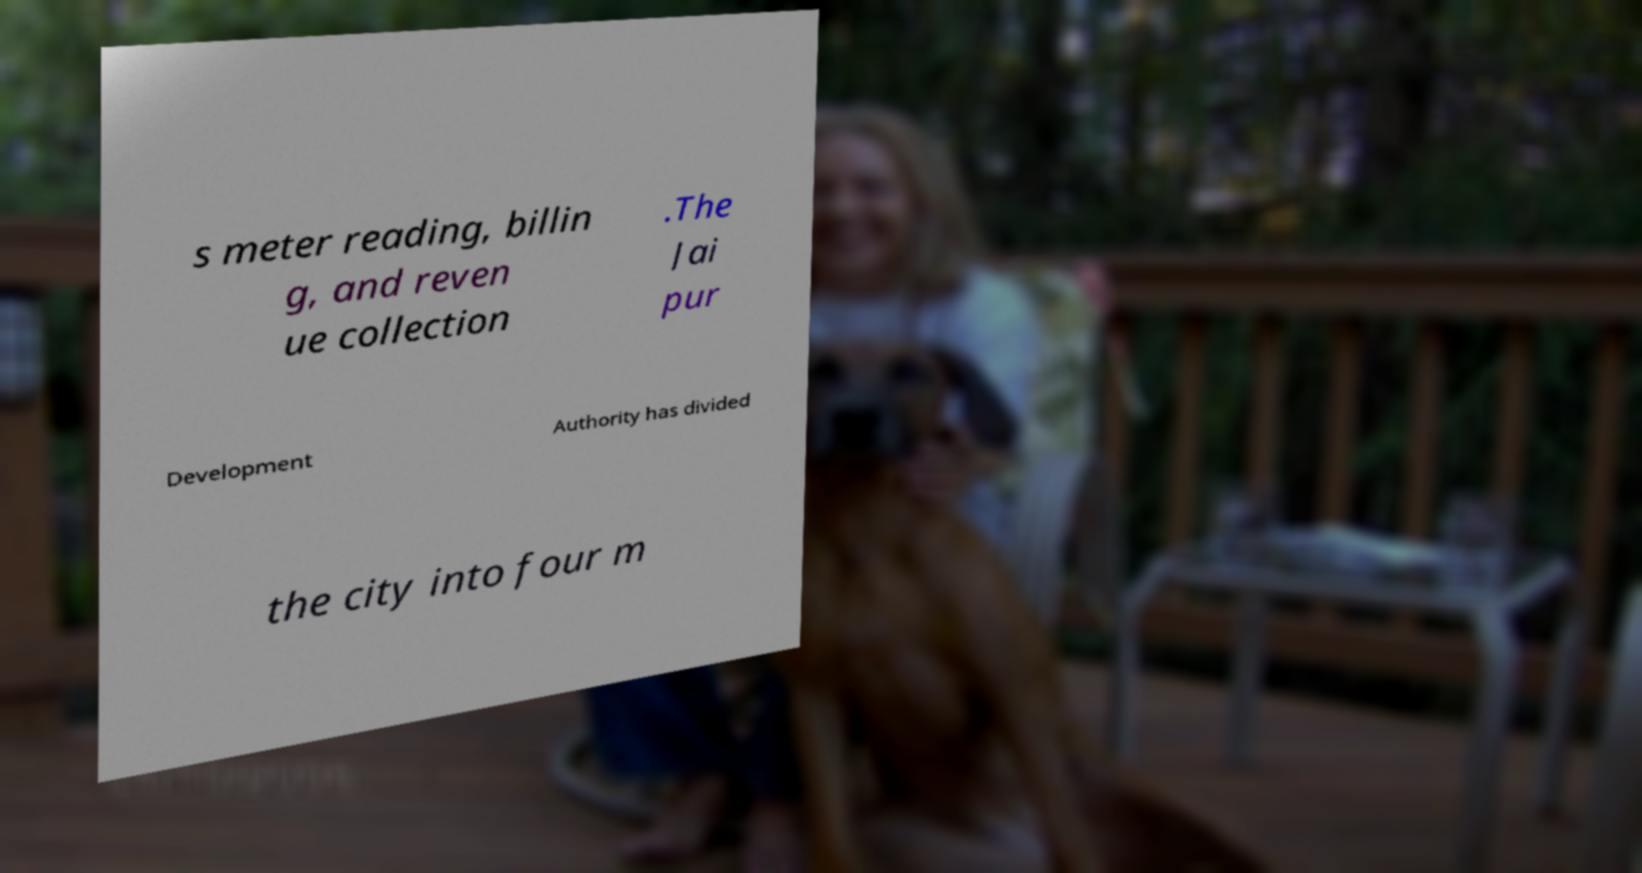Can you read and provide the text displayed in the image?This photo seems to have some interesting text. Can you extract and type it out for me? s meter reading, billin g, and reven ue collection .The Jai pur Development Authority has divided the city into four m 